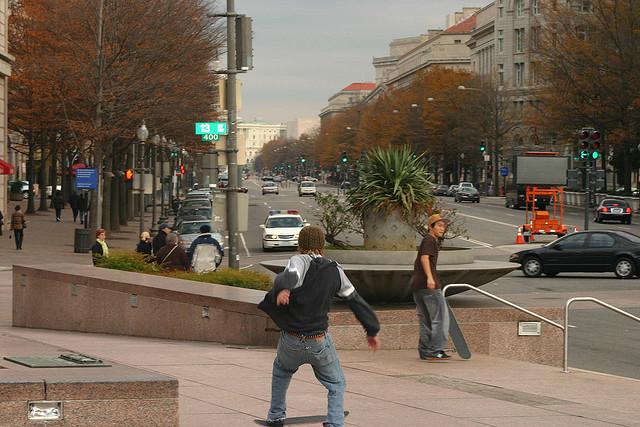Is his cap on backwards?
Keep it brief. No. Is there road construction in the area?
Short answer required. Yes. Is the street wet?
Answer briefly. No. Where are they?
Quick response, please. City. Is the image blurry?
Write a very short answer. No. Why does this male have his left foot placed on the concrete road?
Keep it brief. To stop. How many stair railings can be seen?
Concise answer only. 2. Where is he going?
Give a very brief answer. Skateboarding. Where is the no-left-turn sign?
Concise answer only. Nowhere. What are  the boys riding?
Answer briefly. Skateboards. What is written on the step?
Keep it brief. Nothing. What type of weather is shown in this picture?
Keep it brief. Cloudy. 